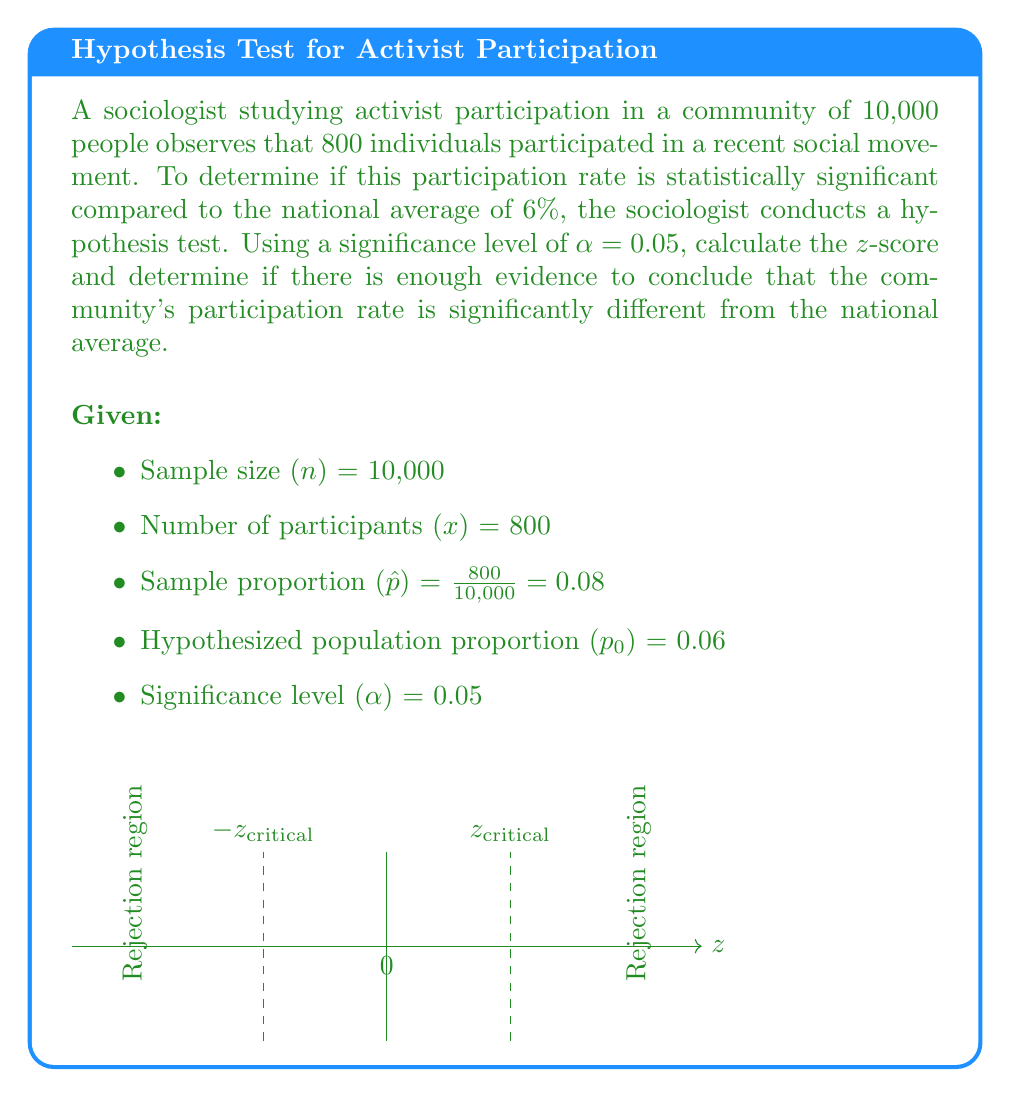What is the answer to this math problem? To analyze the statistical significance, we'll follow these steps:

1) Formulate the null and alternative hypotheses:
   $H_0: p = 0.06$ (participation rate equals national average)
   $H_a: p \neq 0.06$ (participation rate differs from national average)

2) Calculate the standard error of the proportion:
   $SE = \sqrt{\frac{p_0(1-p_0)}{n}} = \sqrt{\frac{0.06(1-0.06)}{10000}} = 0.00238$

3) Calculate the z-score:
   $$z = \frac{\hat{p} - p_0}{SE} = \frac{0.08 - 0.06}{0.00238} = 8.40$$

4) Determine the critical z-value for a two-tailed test at α = 0.05:
   $z_{critical} = \pm 1.96$

5) Compare the calculated z-score to the critical value:
   $|8.40| > 1.96$

6) Make a decision:
   Since the absolute value of the calculated z-score (8.40) is greater than the critical value (1.96), we reject the null hypothesis.

7) Interpret the result:
   There is sufficient evidence to conclude that the community's participation rate (8%) is significantly different from the national average (6%) at the 0.05 significance level.
Answer: Reject $H_0$; participation rate significantly different (z = 8.40, p < 0.05) 